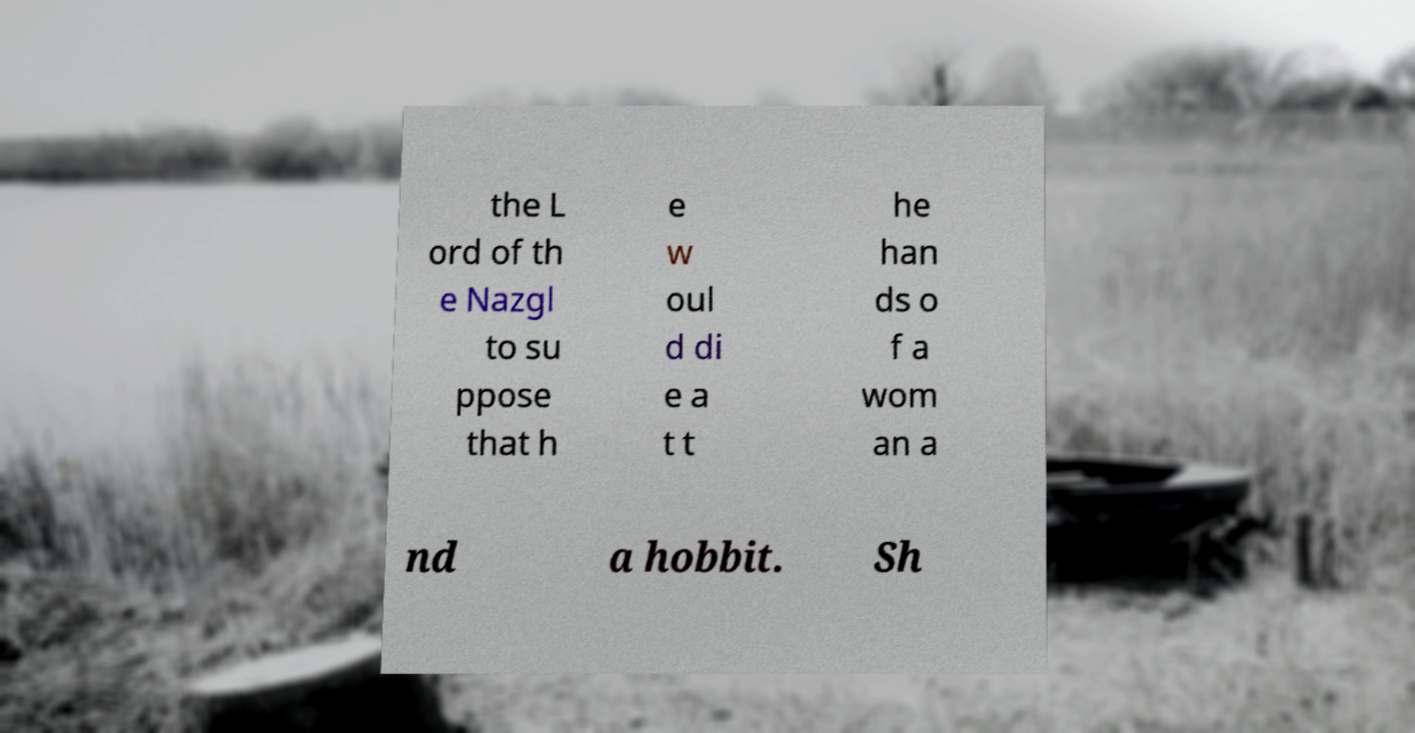There's text embedded in this image that I need extracted. Can you transcribe it verbatim? the L ord of th e Nazgl to su ppose that h e w oul d di e a t t he han ds o f a wom an a nd a hobbit. Sh 